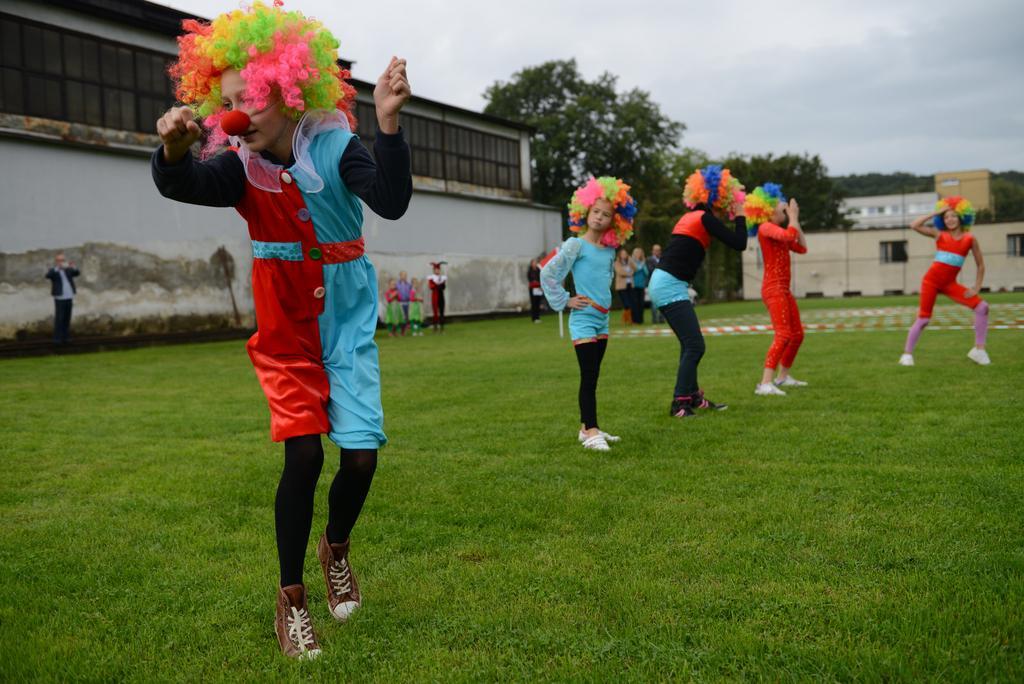How would you summarize this image in a sentence or two? The picture consists of a ground. In this picture we can see people dancing. In the foreground there is grass. In the middle of the picture there are trees and buildings. At the top there is sky. In the middle of the picture we can see people. 